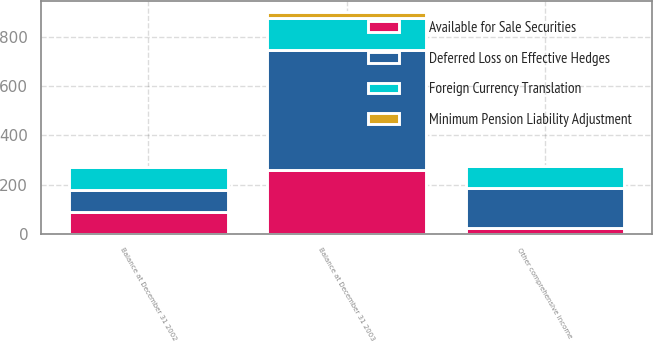Convert chart. <chart><loc_0><loc_0><loc_500><loc_500><stacked_bar_chart><ecel><fcel>Other comprehensive income<fcel>Balance at December 31 2002<fcel>Balance at December 31 2003<nl><fcel>Deferred Loss on Effective Hedges<fcel>161<fcel>89<fcel>491<nl><fcel>Minimum Pension Liability Adjustment<fcel>1<fcel>1<fcel>24<nl><fcel>Available for Sale Securities<fcel>25<fcel>87<fcel>258<nl><fcel>Foreign Currency Translation<fcel>89<fcel>94<fcel>130<nl></chart> 